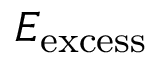<formula> <loc_0><loc_0><loc_500><loc_500>E _ { e x c e s s }</formula> 